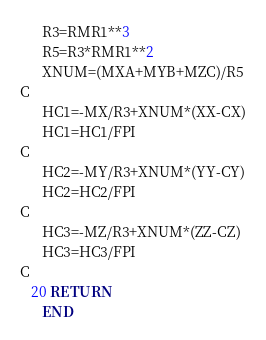<code> <loc_0><loc_0><loc_500><loc_500><_FORTRAN_>      R3=RMR1**3
      R5=R3*RMR1**2
      XNUM=(MXA+MYB+MZC)/R5
C
      HC1=-MX/R3+XNUM*(XX-CX)
      HC1=HC1/FPI
C
      HC2=-MY/R3+XNUM*(YY-CY)
      HC2=HC2/FPI
C
      HC3=-MZ/R3+XNUM*(ZZ-CZ)
      HC3=HC3/FPI
C
   20 RETURN
      END
</code> 